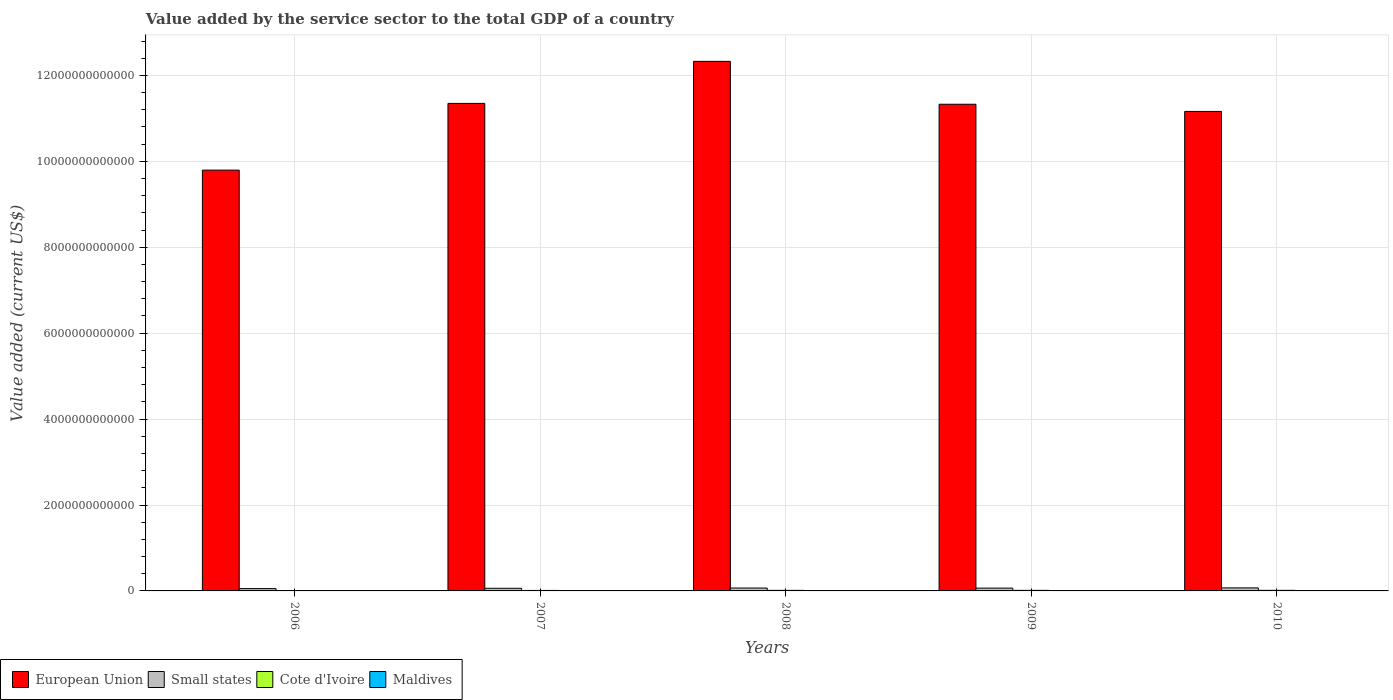Are the number of bars per tick equal to the number of legend labels?
Your response must be concise. Yes. How many bars are there on the 2nd tick from the left?
Ensure brevity in your answer.  4. What is the label of the 1st group of bars from the left?
Make the answer very short. 2006. In how many cases, is the number of bars for a given year not equal to the number of legend labels?
Provide a succinct answer. 0. What is the value added by the service sector to the total GDP in Maldives in 2010?
Your answer should be compact. 1.71e+09. Across all years, what is the maximum value added by the service sector to the total GDP in Small states?
Offer a very short reply. 7.04e+1. Across all years, what is the minimum value added by the service sector to the total GDP in Cote d'Ivoire?
Your answer should be compact. 9.58e+09. In which year was the value added by the service sector to the total GDP in Maldives minimum?
Give a very brief answer. 2006. What is the total value added by the service sector to the total GDP in European Union in the graph?
Offer a terse response. 5.60e+13. What is the difference between the value added by the service sector to the total GDP in Maldives in 2007 and that in 2009?
Your answer should be compact. -3.49e+08. What is the difference between the value added by the service sector to the total GDP in Small states in 2008 and the value added by the service sector to the total GDP in Maldives in 2010?
Provide a succinct answer. 6.54e+1. What is the average value added by the service sector to the total GDP in European Union per year?
Your answer should be compact. 1.12e+13. In the year 2009, what is the difference between the value added by the service sector to the total GDP in Cote d'Ivoire and value added by the service sector to the total GDP in European Union?
Keep it short and to the point. -1.13e+13. In how many years, is the value added by the service sector to the total GDP in Small states greater than 8000000000000 US$?
Offer a very short reply. 0. What is the ratio of the value added by the service sector to the total GDP in Small states in 2006 to that in 2009?
Provide a short and direct response. 0.83. What is the difference between the highest and the second highest value added by the service sector to the total GDP in European Union?
Your answer should be very brief. 9.79e+11. What is the difference between the highest and the lowest value added by the service sector to the total GDP in Cote d'Ivoire?
Offer a terse response. 3.62e+09. What does the 4th bar from the left in 2006 represents?
Make the answer very short. Maldives. What does the 1st bar from the right in 2009 represents?
Provide a succinct answer. Maldives. How many bars are there?
Offer a very short reply. 20. Are all the bars in the graph horizontal?
Ensure brevity in your answer.  No. How many years are there in the graph?
Your response must be concise. 5. What is the difference between two consecutive major ticks on the Y-axis?
Provide a short and direct response. 2.00e+12. Does the graph contain any zero values?
Your answer should be very brief. No. Where does the legend appear in the graph?
Ensure brevity in your answer.  Bottom left. What is the title of the graph?
Keep it short and to the point. Value added by the service sector to the total GDP of a country. Does "Armenia" appear as one of the legend labels in the graph?
Your answer should be compact. No. What is the label or title of the Y-axis?
Make the answer very short. Value added (current US$). What is the Value added (current US$) in European Union in 2006?
Keep it short and to the point. 9.80e+12. What is the Value added (current US$) in Small states in 2006?
Your answer should be very brief. 5.44e+1. What is the Value added (current US$) in Cote d'Ivoire in 2006?
Make the answer very short. 9.58e+09. What is the Value added (current US$) of Maldives in 2006?
Provide a succinct answer. 1.04e+09. What is the Value added (current US$) in European Union in 2007?
Offer a very short reply. 1.13e+13. What is the Value added (current US$) of Small states in 2007?
Give a very brief answer. 6.14e+1. What is the Value added (current US$) in Cote d'Ivoire in 2007?
Provide a succinct answer. 1.11e+1. What is the Value added (current US$) of Maldives in 2007?
Offer a terse response. 1.25e+09. What is the Value added (current US$) of European Union in 2008?
Make the answer very short. 1.23e+13. What is the Value added (current US$) of Small states in 2008?
Offer a very short reply. 6.71e+1. What is the Value added (current US$) of Cote d'Ivoire in 2008?
Offer a terse response. 1.28e+1. What is the Value added (current US$) in Maldives in 2008?
Give a very brief answer. 1.44e+09. What is the Value added (current US$) of European Union in 2009?
Provide a succinct answer. 1.13e+13. What is the Value added (current US$) of Small states in 2009?
Ensure brevity in your answer.  6.54e+1. What is the Value added (current US$) in Cote d'Ivoire in 2009?
Make the answer very short. 1.30e+1. What is the Value added (current US$) in Maldives in 2009?
Offer a terse response. 1.60e+09. What is the Value added (current US$) in European Union in 2010?
Provide a short and direct response. 1.12e+13. What is the Value added (current US$) in Small states in 2010?
Provide a succinct answer. 7.04e+1. What is the Value added (current US$) in Cote d'Ivoire in 2010?
Your response must be concise. 1.32e+1. What is the Value added (current US$) in Maldives in 2010?
Give a very brief answer. 1.71e+09. Across all years, what is the maximum Value added (current US$) of European Union?
Ensure brevity in your answer.  1.23e+13. Across all years, what is the maximum Value added (current US$) of Small states?
Your answer should be very brief. 7.04e+1. Across all years, what is the maximum Value added (current US$) of Cote d'Ivoire?
Ensure brevity in your answer.  1.32e+1. Across all years, what is the maximum Value added (current US$) in Maldives?
Provide a succinct answer. 1.71e+09. Across all years, what is the minimum Value added (current US$) in European Union?
Offer a very short reply. 9.80e+12. Across all years, what is the minimum Value added (current US$) in Small states?
Offer a terse response. 5.44e+1. Across all years, what is the minimum Value added (current US$) of Cote d'Ivoire?
Offer a very short reply. 9.58e+09. Across all years, what is the minimum Value added (current US$) of Maldives?
Give a very brief answer. 1.04e+09. What is the total Value added (current US$) of European Union in the graph?
Your response must be concise. 5.60e+13. What is the total Value added (current US$) in Small states in the graph?
Offer a very short reply. 3.19e+11. What is the total Value added (current US$) in Cote d'Ivoire in the graph?
Make the answer very short. 5.98e+1. What is the total Value added (current US$) of Maldives in the graph?
Provide a succinct answer. 7.05e+09. What is the difference between the Value added (current US$) of European Union in 2006 and that in 2007?
Keep it short and to the point. -1.55e+12. What is the difference between the Value added (current US$) in Small states in 2006 and that in 2007?
Ensure brevity in your answer.  -7.05e+09. What is the difference between the Value added (current US$) of Cote d'Ivoire in 2006 and that in 2007?
Offer a very short reply. -1.55e+09. What is the difference between the Value added (current US$) of Maldives in 2006 and that in 2007?
Your answer should be very brief. -2.07e+08. What is the difference between the Value added (current US$) in European Union in 2006 and that in 2008?
Offer a very short reply. -2.53e+12. What is the difference between the Value added (current US$) of Small states in 2006 and that in 2008?
Give a very brief answer. -1.27e+1. What is the difference between the Value added (current US$) of Cote d'Ivoire in 2006 and that in 2008?
Your answer should be compact. -3.24e+09. What is the difference between the Value added (current US$) of Maldives in 2006 and that in 2008?
Make the answer very short. -4.00e+08. What is the difference between the Value added (current US$) of European Union in 2006 and that in 2009?
Offer a very short reply. -1.53e+12. What is the difference between the Value added (current US$) of Small states in 2006 and that in 2009?
Provide a succinct answer. -1.10e+1. What is the difference between the Value added (current US$) of Cote d'Ivoire in 2006 and that in 2009?
Provide a succinct answer. -3.47e+09. What is the difference between the Value added (current US$) of Maldives in 2006 and that in 2009?
Offer a terse response. -5.57e+08. What is the difference between the Value added (current US$) of European Union in 2006 and that in 2010?
Keep it short and to the point. -1.37e+12. What is the difference between the Value added (current US$) of Small states in 2006 and that in 2010?
Your answer should be compact. -1.60e+1. What is the difference between the Value added (current US$) in Cote d'Ivoire in 2006 and that in 2010?
Your response must be concise. -3.62e+09. What is the difference between the Value added (current US$) of Maldives in 2006 and that in 2010?
Offer a very short reply. -6.67e+08. What is the difference between the Value added (current US$) in European Union in 2007 and that in 2008?
Your answer should be very brief. -9.79e+11. What is the difference between the Value added (current US$) of Small states in 2007 and that in 2008?
Offer a terse response. -5.63e+09. What is the difference between the Value added (current US$) in Cote d'Ivoire in 2007 and that in 2008?
Your response must be concise. -1.69e+09. What is the difference between the Value added (current US$) of Maldives in 2007 and that in 2008?
Your answer should be very brief. -1.93e+08. What is the difference between the Value added (current US$) of European Union in 2007 and that in 2009?
Keep it short and to the point. 1.98e+1. What is the difference between the Value added (current US$) of Small states in 2007 and that in 2009?
Offer a very short reply. -3.94e+09. What is the difference between the Value added (current US$) of Cote d'Ivoire in 2007 and that in 2009?
Your answer should be compact. -1.92e+09. What is the difference between the Value added (current US$) of Maldives in 2007 and that in 2009?
Your answer should be compact. -3.49e+08. What is the difference between the Value added (current US$) in European Union in 2007 and that in 2010?
Give a very brief answer. 1.87e+11. What is the difference between the Value added (current US$) of Small states in 2007 and that in 2010?
Make the answer very short. -8.96e+09. What is the difference between the Value added (current US$) in Cote d'Ivoire in 2007 and that in 2010?
Make the answer very short. -2.07e+09. What is the difference between the Value added (current US$) in Maldives in 2007 and that in 2010?
Offer a terse response. -4.60e+08. What is the difference between the Value added (current US$) in European Union in 2008 and that in 2009?
Keep it short and to the point. 9.98e+11. What is the difference between the Value added (current US$) in Small states in 2008 and that in 2009?
Your response must be concise. 1.69e+09. What is the difference between the Value added (current US$) of Cote d'Ivoire in 2008 and that in 2009?
Provide a short and direct response. -2.27e+08. What is the difference between the Value added (current US$) of Maldives in 2008 and that in 2009?
Give a very brief answer. -1.57e+08. What is the difference between the Value added (current US$) of European Union in 2008 and that in 2010?
Your answer should be compact. 1.17e+12. What is the difference between the Value added (current US$) in Small states in 2008 and that in 2010?
Provide a short and direct response. -3.32e+09. What is the difference between the Value added (current US$) of Cote d'Ivoire in 2008 and that in 2010?
Your response must be concise. -3.82e+08. What is the difference between the Value added (current US$) of Maldives in 2008 and that in 2010?
Give a very brief answer. -2.67e+08. What is the difference between the Value added (current US$) in European Union in 2009 and that in 2010?
Your response must be concise. 1.67e+11. What is the difference between the Value added (current US$) of Small states in 2009 and that in 2010?
Make the answer very short. -5.01e+09. What is the difference between the Value added (current US$) in Cote d'Ivoire in 2009 and that in 2010?
Provide a short and direct response. -1.54e+08. What is the difference between the Value added (current US$) of Maldives in 2009 and that in 2010?
Make the answer very short. -1.10e+08. What is the difference between the Value added (current US$) of European Union in 2006 and the Value added (current US$) of Small states in 2007?
Your answer should be very brief. 9.73e+12. What is the difference between the Value added (current US$) in European Union in 2006 and the Value added (current US$) in Cote d'Ivoire in 2007?
Make the answer very short. 9.78e+12. What is the difference between the Value added (current US$) of European Union in 2006 and the Value added (current US$) of Maldives in 2007?
Keep it short and to the point. 9.79e+12. What is the difference between the Value added (current US$) in Small states in 2006 and the Value added (current US$) in Cote d'Ivoire in 2007?
Provide a short and direct response. 4.32e+1. What is the difference between the Value added (current US$) in Small states in 2006 and the Value added (current US$) in Maldives in 2007?
Provide a short and direct response. 5.31e+1. What is the difference between the Value added (current US$) in Cote d'Ivoire in 2006 and the Value added (current US$) in Maldives in 2007?
Offer a terse response. 8.33e+09. What is the difference between the Value added (current US$) in European Union in 2006 and the Value added (current US$) in Small states in 2008?
Offer a terse response. 9.73e+12. What is the difference between the Value added (current US$) in European Union in 2006 and the Value added (current US$) in Cote d'Ivoire in 2008?
Ensure brevity in your answer.  9.78e+12. What is the difference between the Value added (current US$) of European Union in 2006 and the Value added (current US$) of Maldives in 2008?
Make the answer very short. 9.79e+12. What is the difference between the Value added (current US$) of Small states in 2006 and the Value added (current US$) of Cote d'Ivoire in 2008?
Ensure brevity in your answer.  4.16e+1. What is the difference between the Value added (current US$) in Small states in 2006 and the Value added (current US$) in Maldives in 2008?
Offer a very short reply. 5.29e+1. What is the difference between the Value added (current US$) of Cote d'Ivoire in 2006 and the Value added (current US$) of Maldives in 2008?
Your answer should be compact. 8.14e+09. What is the difference between the Value added (current US$) in European Union in 2006 and the Value added (current US$) in Small states in 2009?
Your response must be concise. 9.73e+12. What is the difference between the Value added (current US$) in European Union in 2006 and the Value added (current US$) in Cote d'Ivoire in 2009?
Provide a short and direct response. 9.78e+12. What is the difference between the Value added (current US$) of European Union in 2006 and the Value added (current US$) of Maldives in 2009?
Offer a very short reply. 9.79e+12. What is the difference between the Value added (current US$) in Small states in 2006 and the Value added (current US$) in Cote d'Ivoire in 2009?
Keep it short and to the point. 4.13e+1. What is the difference between the Value added (current US$) in Small states in 2006 and the Value added (current US$) in Maldives in 2009?
Provide a short and direct response. 5.28e+1. What is the difference between the Value added (current US$) in Cote d'Ivoire in 2006 and the Value added (current US$) in Maldives in 2009?
Offer a very short reply. 7.98e+09. What is the difference between the Value added (current US$) of European Union in 2006 and the Value added (current US$) of Small states in 2010?
Ensure brevity in your answer.  9.73e+12. What is the difference between the Value added (current US$) of European Union in 2006 and the Value added (current US$) of Cote d'Ivoire in 2010?
Provide a short and direct response. 9.78e+12. What is the difference between the Value added (current US$) in European Union in 2006 and the Value added (current US$) in Maldives in 2010?
Keep it short and to the point. 9.79e+12. What is the difference between the Value added (current US$) of Small states in 2006 and the Value added (current US$) of Cote d'Ivoire in 2010?
Offer a terse response. 4.12e+1. What is the difference between the Value added (current US$) in Small states in 2006 and the Value added (current US$) in Maldives in 2010?
Your response must be concise. 5.27e+1. What is the difference between the Value added (current US$) of Cote d'Ivoire in 2006 and the Value added (current US$) of Maldives in 2010?
Offer a terse response. 7.87e+09. What is the difference between the Value added (current US$) of European Union in 2007 and the Value added (current US$) of Small states in 2008?
Give a very brief answer. 1.13e+13. What is the difference between the Value added (current US$) of European Union in 2007 and the Value added (current US$) of Cote d'Ivoire in 2008?
Your answer should be very brief. 1.13e+13. What is the difference between the Value added (current US$) in European Union in 2007 and the Value added (current US$) in Maldives in 2008?
Offer a very short reply. 1.13e+13. What is the difference between the Value added (current US$) of Small states in 2007 and the Value added (current US$) of Cote d'Ivoire in 2008?
Offer a terse response. 4.86e+1. What is the difference between the Value added (current US$) of Small states in 2007 and the Value added (current US$) of Maldives in 2008?
Offer a very short reply. 6.00e+1. What is the difference between the Value added (current US$) in Cote d'Ivoire in 2007 and the Value added (current US$) in Maldives in 2008?
Keep it short and to the point. 9.69e+09. What is the difference between the Value added (current US$) in European Union in 2007 and the Value added (current US$) in Small states in 2009?
Your response must be concise. 1.13e+13. What is the difference between the Value added (current US$) in European Union in 2007 and the Value added (current US$) in Cote d'Ivoire in 2009?
Ensure brevity in your answer.  1.13e+13. What is the difference between the Value added (current US$) of European Union in 2007 and the Value added (current US$) of Maldives in 2009?
Make the answer very short. 1.13e+13. What is the difference between the Value added (current US$) in Small states in 2007 and the Value added (current US$) in Cote d'Ivoire in 2009?
Offer a terse response. 4.84e+1. What is the difference between the Value added (current US$) in Small states in 2007 and the Value added (current US$) in Maldives in 2009?
Provide a succinct answer. 5.98e+1. What is the difference between the Value added (current US$) in Cote d'Ivoire in 2007 and the Value added (current US$) in Maldives in 2009?
Provide a succinct answer. 9.53e+09. What is the difference between the Value added (current US$) of European Union in 2007 and the Value added (current US$) of Small states in 2010?
Keep it short and to the point. 1.13e+13. What is the difference between the Value added (current US$) in European Union in 2007 and the Value added (current US$) in Cote d'Ivoire in 2010?
Your response must be concise. 1.13e+13. What is the difference between the Value added (current US$) of European Union in 2007 and the Value added (current US$) of Maldives in 2010?
Your answer should be very brief. 1.13e+13. What is the difference between the Value added (current US$) in Small states in 2007 and the Value added (current US$) in Cote d'Ivoire in 2010?
Your answer should be very brief. 4.82e+1. What is the difference between the Value added (current US$) of Small states in 2007 and the Value added (current US$) of Maldives in 2010?
Your response must be concise. 5.97e+1. What is the difference between the Value added (current US$) of Cote d'Ivoire in 2007 and the Value added (current US$) of Maldives in 2010?
Offer a very short reply. 9.42e+09. What is the difference between the Value added (current US$) of European Union in 2008 and the Value added (current US$) of Small states in 2009?
Provide a short and direct response. 1.23e+13. What is the difference between the Value added (current US$) in European Union in 2008 and the Value added (current US$) in Cote d'Ivoire in 2009?
Ensure brevity in your answer.  1.23e+13. What is the difference between the Value added (current US$) in European Union in 2008 and the Value added (current US$) in Maldives in 2009?
Offer a very short reply. 1.23e+13. What is the difference between the Value added (current US$) of Small states in 2008 and the Value added (current US$) of Cote d'Ivoire in 2009?
Your answer should be very brief. 5.40e+1. What is the difference between the Value added (current US$) of Small states in 2008 and the Value added (current US$) of Maldives in 2009?
Keep it short and to the point. 6.55e+1. What is the difference between the Value added (current US$) in Cote d'Ivoire in 2008 and the Value added (current US$) in Maldives in 2009?
Keep it short and to the point. 1.12e+1. What is the difference between the Value added (current US$) in European Union in 2008 and the Value added (current US$) in Small states in 2010?
Your response must be concise. 1.23e+13. What is the difference between the Value added (current US$) in European Union in 2008 and the Value added (current US$) in Cote d'Ivoire in 2010?
Your response must be concise. 1.23e+13. What is the difference between the Value added (current US$) in European Union in 2008 and the Value added (current US$) in Maldives in 2010?
Your answer should be very brief. 1.23e+13. What is the difference between the Value added (current US$) in Small states in 2008 and the Value added (current US$) in Cote d'Ivoire in 2010?
Your answer should be very brief. 5.39e+1. What is the difference between the Value added (current US$) in Small states in 2008 and the Value added (current US$) in Maldives in 2010?
Your response must be concise. 6.54e+1. What is the difference between the Value added (current US$) in Cote d'Ivoire in 2008 and the Value added (current US$) in Maldives in 2010?
Make the answer very short. 1.11e+1. What is the difference between the Value added (current US$) in European Union in 2009 and the Value added (current US$) in Small states in 2010?
Your response must be concise. 1.13e+13. What is the difference between the Value added (current US$) in European Union in 2009 and the Value added (current US$) in Cote d'Ivoire in 2010?
Provide a succinct answer. 1.13e+13. What is the difference between the Value added (current US$) in European Union in 2009 and the Value added (current US$) in Maldives in 2010?
Keep it short and to the point. 1.13e+13. What is the difference between the Value added (current US$) in Small states in 2009 and the Value added (current US$) in Cote d'Ivoire in 2010?
Keep it short and to the point. 5.22e+1. What is the difference between the Value added (current US$) in Small states in 2009 and the Value added (current US$) in Maldives in 2010?
Provide a short and direct response. 6.37e+1. What is the difference between the Value added (current US$) of Cote d'Ivoire in 2009 and the Value added (current US$) of Maldives in 2010?
Provide a short and direct response. 1.13e+1. What is the average Value added (current US$) in European Union per year?
Ensure brevity in your answer.  1.12e+13. What is the average Value added (current US$) of Small states per year?
Offer a terse response. 6.37e+1. What is the average Value added (current US$) of Cote d'Ivoire per year?
Offer a terse response. 1.20e+1. What is the average Value added (current US$) in Maldives per year?
Give a very brief answer. 1.41e+09. In the year 2006, what is the difference between the Value added (current US$) in European Union and Value added (current US$) in Small states?
Ensure brevity in your answer.  9.74e+12. In the year 2006, what is the difference between the Value added (current US$) of European Union and Value added (current US$) of Cote d'Ivoire?
Your answer should be compact. 9.79e+12. In the year 2006, what is the difference between the Value added (current US$) in European Union and Value added (current US$) in Maldives?
Your answer should be compact. 9.79e+12. In the year 2006, what is the difference between the Value added (current US$) of Small states and Value added (current US$) of Cote d'Ivoire?
Your answer should be compact. 4.48e+1. In the year 2006, what is the difference between the Value added (current US$) of Small states and Value added (current US$) of Maldives?
Ensure brevity in your answer.  5.33e+1. In the year 2006, what is the difference between the Value added (current US$) in Cote d'Ivoire and Value added (current US$) in Maldives?
Keep it short and to the point. 8.54e+09. In the year 2007, what is the difference between the Value added (current US$) of European Union and Value added (current US$) of Small states?
Your answer should be compact. 1.13e+13. In the year 2007, what is the difference between the Value added (current US$) in European Union and Value added (current US$) in Cote d'Ivoire?
Your answer should be compact. 1.13e+13. In the year 2007, what is the difference between the Value added (current US$) in European Union and Value added (current US$) in Maldives?
Ensure brevity in your answer.  1.13e+13. In the year 2007, what is the difference between the Value added (current US$) in Small states and Value added (current US$) in Cote d'Ivoire?
Provide a succinct answer. 5.03e+1. In the year 2007, what is the difference between the Value added (current US$) of Small states and Value added (current US$) of Maldives?
Offer a terse response. 6.02e+1. In the year 2007, what is the difference between the Value added (current US$) of Cote d'Ivoire and Value added (current US$) of Maldives?
Ensure brevity in your answer.  9.88e+09. In the year 2008, what is the difference between the Value added (current US$) in European Union and Value added (current US$) in Small states?
Provide a succinct answer. 1.23e+13. In the year 2008, what is the difference between the Value added (current US$) in European Union and Value added (current US$) in Cote d'Ivoire?
Your response must be concise. 1.23e+13. In the year 2008, what is the difference between the Value added (current US$) of European Union and Value added (current US$) of Maldives?
Provide a short and direct response. 1.23e+13. In the year 2008, what is the difference between the Value added (current US$) in Small states and Value added (current US$) in Cote d'Ivoire?
Provide a succinct answer. 5.42e+1. In the year 2008, what is the difference between the Value added (current US$) of Small states and Value added (current US$) of Maldives?
Make the answer very short. 6.56e+1. In the year 2008, what is the difference between the Value added (current US$) in Cote d'Ivoire and Value added (current US$) in Maldives?
Keep it short and to the point. 1.14e+1. In the year 2009, what is the difference between the Value added (current US$) of European Union and Value added (current US$) of Small states?
Make the answer very short. 1.13e+13. In the year 2009, what is the difference between the Value added (current US$) in European Union and Value added (current US$) in Cote d'Ivoire?
Keep it short and to the point. 1.13e+13. In the year 2009, what is the difference between the Value added (current US$) in European Union and Value added (current US$) in Maldives?
Offer a very short reply. 1.13e+13. In the year 2009, what is the difference between the Value added (current US$) in Small states and Value added (current US$) in Cote d'Ivoire?
Your answer should be very brief. 5.23e+1. In the year 2009, what is the difference between the Value added (current US$) of Small states and Value added (current US$) of Maldives?
Make the answer very short. 6.38e+1. In the year 2009, what is the difference between the Value added (current US$) of Cote d'Ivoire and Value added (current US$) of Maldives?
Keep it short and to the point. 1.14e+1. In the year 2010, what is the difference between the Value added (current US$) in European Union and Value added (current US$) in Small states?
Ensure brevity in your answer.  1.11e+13. In the year 2010, what is the difference between the Value added (current US$) of European Union and Value added (current US$) of Cote d'Ivoire?
Ensure brevity in your answer.  1.11e+13. In the year 2010, what is the difference between the Value added (current US$) of European Union and Value added (current US$) of Maldives?
Keep it short and to the point. 1.12e+13. In the year 2010, what is the difference between the Value added (current US$) in Small states and Value added (current US$) in Cote d'Ivoire?
Ensure brevity in your answer.  5.72e+1. In the year 2010, what is the difference between the Value added (current US$) of Small states and Value added (current US$) of Maldives?
Provide a short and direct response. 6.87e+1. In the year 2010, what is the difference between the Value added (current US$) of Cote d'Ivoire and Value added (current US$) of Maldives?
Your answer should be compact. 1.15e+1. What is the ratio of the Value added (current US$) of European Union in 2006 to that in 2007?
Keep it short and to the point. 0.86. What is the ratio of the Value added (current US$) of Small states in 2006 to that in 2007?
Your response must be concise. 0.89. What is the ratio of the Value added (current US$) in Cote d'Ivoire in 2006 to that in 2007?
Offer a terse response. 0.86. What is the ratio of the Value added (current US$) of Maldives in 2006 to that in 2007?
Provide a succinct answer. 0.83. What is the ratio of the Value added (current US$) in European Union in 2006 to that in 2008?
Make the answer very short. 0.79. What is the ratio of the Value added (current US$) of Small states in 2006 to that in 2008?
Give a very brief answer. 0.81. What is the ratio of the Value added (current US$) of Cote d'Ivoire in 2006 to that in 2008?
Provide a succinct answer. 0.75. What is the ratio of the Value added (current US$) in Maldives in 2006 to that in 2008?
Provide a succinct answer. 0.72. What is the ratio of the Value added (current US$) of European Union in 2006 to that in 2009?
Ensure brevity in your answer.  0.86. What is the ratio of the Value added (current US$) in Small states in 2006 to that in 2009?
Make the answer very short. 0.83. What is the ratio of the Value added (current US$) of Cote d'Ivoire in 2006 to that in 2009?
Provide a succinct answer. 0.73. What is the ratio of the Value added (current US$) in Maldives in 2006 to that in 2009?
Keep it short and to the point. 0.65. What is the ratio of the Value added (current US$) in European Union in 2006 to that in 2010?
Provide a succinct answer. 0.88. What is the ratio of the Value added (current US$) in Small states in 2006 to that in 2010?
Offer a terse response. 0.77. What is the ratio of the Value added (current US$) of Cote d'Ivoire in 2006 to that in 2010?
Your answer should be very brief. 0.73. What is the ratio of the Value added (current US$) of Maldives in 2006 to that in 2010?
Keep it short and to the point. 0.61. What is the ratio of the Value added (current US$) of European Union in 2007 to that in 2008?
Make the answer very short. 0.92. What is the ratio of the Value added (current US$) of Small states in 2007 to that in 2008?
Keep it short and to the point. 0.92. What is the ratio of the Value added (current US$) in Cote d'Ivoire in 2007 to that in 2008?
Ensure brevity in your answer.  0.87. What is the ratio of the Value added (current US$) in Maldives in 2007 to that in 2008?
Provide a succinct answer. 0.87. What is the ratio of the Value added (current US$) of Small states in 2007 to that in 2009?
Provide a short and direct response. 0.94. What is the ratio of the Value added (current US$) in Cote d'Ivoire in 2007 to that in 2009?
Give a very brief answer. 0.85. What is the ratio of the Value added (current US$) of Maldives in 2007 to that in 2009?
Make the answer very short. 0.78. What is the ratio of the Value added (current US$) in European Union in 2007 to that in 2010?
Give a very brief answer. 1.02. What is the ratio of the Value added (current US$) of Small states in 2007 to that in 2010?
Provide a succinct answer. 0.87. What is the ratio of the Value added (current US$) of Cote d'Ivoire in 2007 to that in 2010?
Provide a short and direct response. 0.84. What is the ratio of the Value added (current US$) of Maldives in 2007 to that in 2010?
Give a very brief answer. 0.73. What is the ratio of the Value added (current US$) of European Union in 2008 to that in 2009?
Your answer should be compact. 1.09. What is the ratio of the Value added (current US$) in Small states in 2008 to that in 2009?
Your response must be concise. 1.03. What is the ratio of the Value added (current US$) in Cote d'Ivoire in 2008 to that in 2009?
Ensure brevity in your answer.  0.98. What is the ratio of the Value added (current US$) of Maldives in 2008 to that in 2009?
Your answer should be compact. 0.9. What is the ratio of the Value added (current US$) in European Union in 2008 to that in 2010?
Make the answer very short. 1.1. What is the ratio of the Value added (current US$) of Small states in 2008 to that in 2010?
Keep it short and to the point. 0.95. What is the ratio of the Value added (current US$) in Cote d'Ivoire in 2008 to that in 2010?
Provide a short and direct response. 0.97. What is the ratio of the Value added (current US$) in Maldives in 2008 to that in 2010?
Give a very brief answer. 0.84. What is the ratio of the Value added (current US$) of Small states in 2009 to that in 2010?
Offer a terse response. 0.93. What is the ratio of the Value added (current US$) of Cote d'Ivoire in 2009 to that in 2010?
Provide a succinct answer. 0.99. What is the ratio of the Value added (current US$) of Maldives in 2009 to that in 2010?
Keep it short and to the point. 0.94. What is the difference between the highest and the second highest Value added (current US$) in European Union?
Ensure brevity in your answer.  9.79e+11. What is the difference between the highest and the second highest Value added (current US$) in Small states?
Offer a very short reply. 3.32e+09. What is the difference between the highest and the second highest Value added (current US$) in Cote d'Ivoire?
Your answer should be very brief. 1.54e+08. What is the difference between the highest and the second highest Value added (current US$) in Maldives?
Ensure brevity in your answer.  1.10e+08. What is the difference between the highest and the lowest Value added (current US$) in European Union?
Offer a terse response. 2.53e+12. What is the difference between the highest and the lowest Value added (current US$) in Small states?
Ensure brevity in your answer.  1.60e+1. What is the difference between the highest and the lowest Value added (current US$) of Cote d'Ivoire?
Your answer should be very brief. 3.62e+09. What is the difference between the highest and the lowest Value added (current US$) of Maldives?
Offer a terse response. 6.67e+08. 